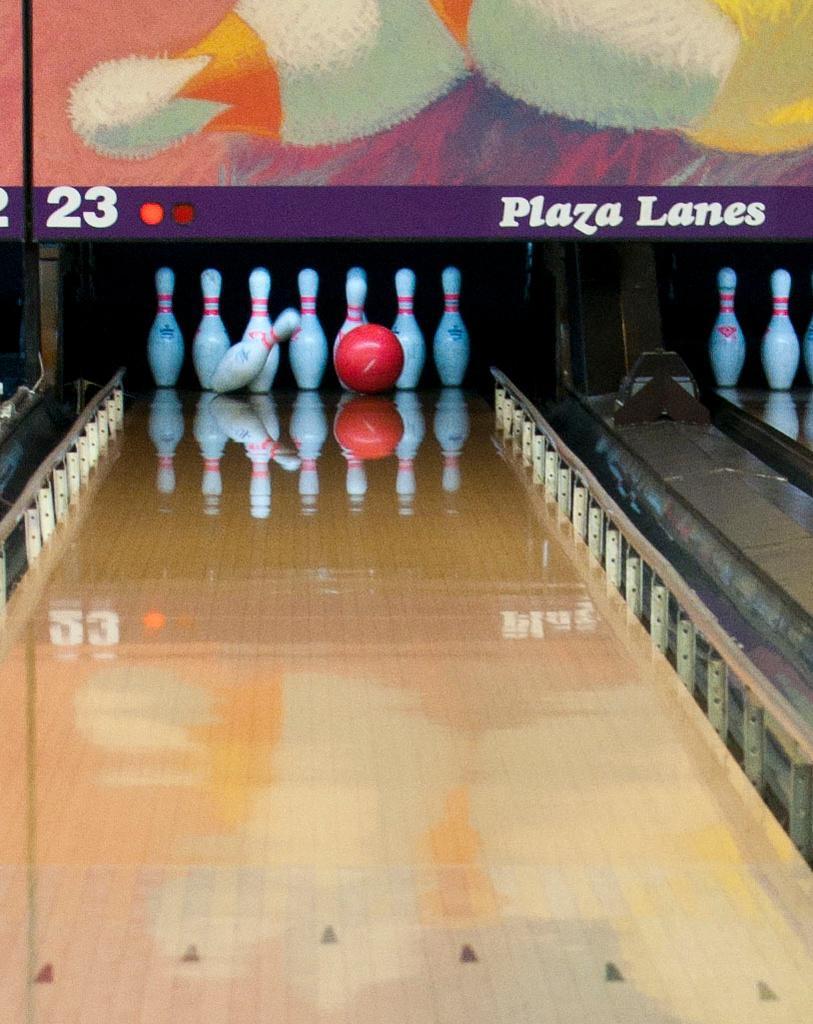Could you give a brief overview of what you see in this image? In this image we can see a bowling ball and group of pins placed on the wood surface. In the background, we can see a signboard with some text on it. 